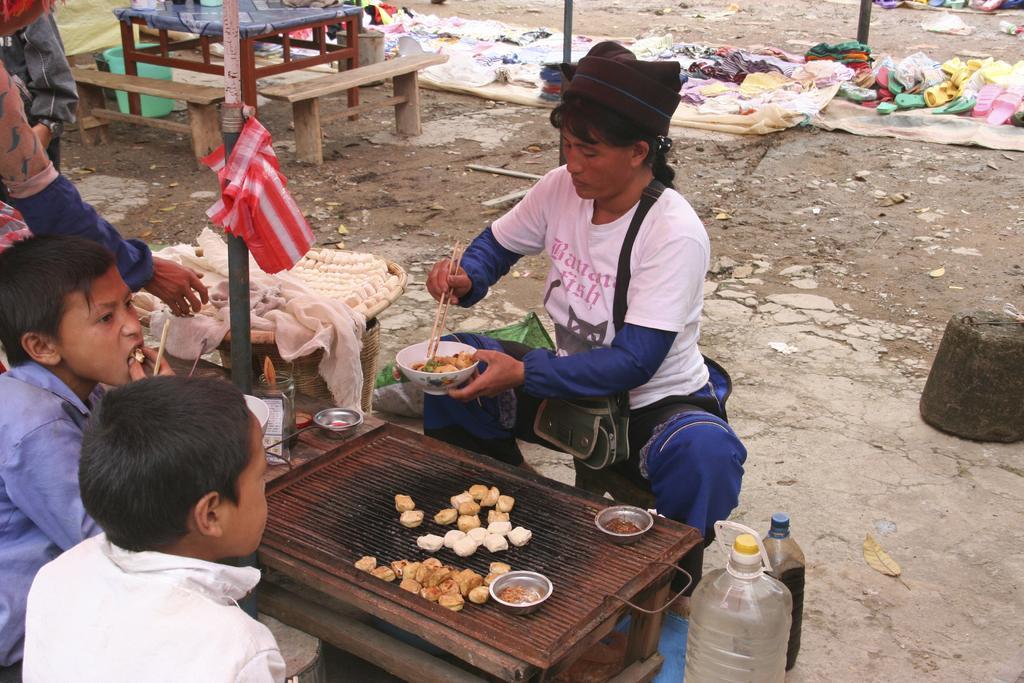Can you describe this image briefly? This picture is taken from the outside of the city. In this image, in the left corner, we can see two boys sitting on the chair in front of the table. In the middle of the image, we can see a person sitting and holding a bowl and chopsticks in hand and the person is sitting in front of the table, on the table, we can see two cups with some food items, we can also see some food items on the table. On the right side, we can see two bottles filled with some liquid. On the left side, we can also see hand of a person. On the left side, we can also see another table, on the table, we can see white color cloth. On the left side, we can see a pole, on the pole, we can see a red color cloth. On the right side, we can see a table. In the background, we can see some clothes, pole, table, chairs. At the bottom, we can see a land with some stones. 